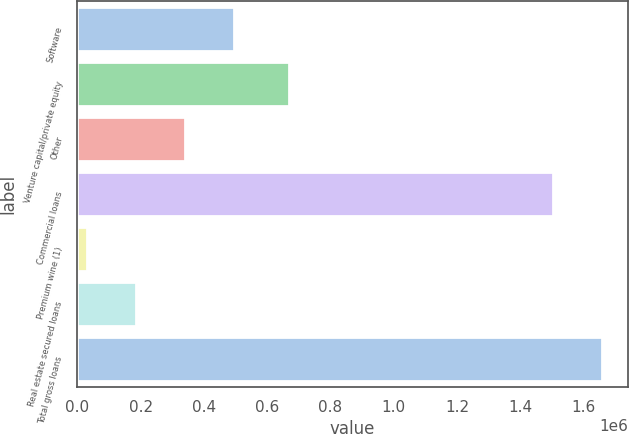Convert chart to OTSL. <chart><loc_0><loc_0><loc_500><loc_500><bar_chart><fcel>Software<fcel>Venture capital/private equity<fcel>Other<fcel>Commercial loans<fcel>Premium wine (1)<fcel>Real estate secured loans<fcel>Total gross loans<nl><fcel>495442<fcel>669912<fcel>340795<fcel>1.50147e+06<fcel>31500<fcel>186147<fcel>1.65612e+06<nl></chart> 